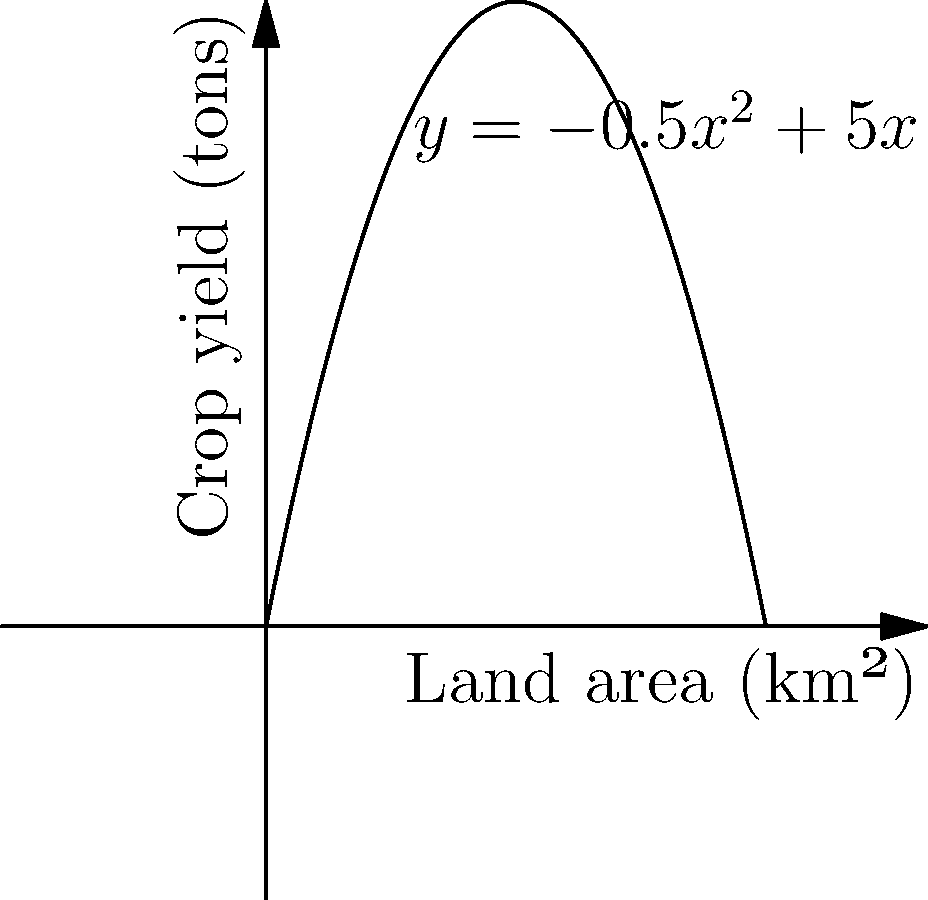In ancient Mesopotamia, agricultural output was crucial for sustaining the civilization. Archaeologists have modeled the relationship between land area cultivated and crop yield using the function $y = -0.5x^2 + 5x$, where $x$ represents the land area in square kilometers and $y$ represents the crop yield in tons. What is the optimal amount of land to cultivate to maximize crop yield, and what is the maximum yield? To find the optimal land area and maximum yield, we need to follow these steps:

1) The function $y = -0.5x^2 + 5x$ is a parabola that opens downward due to the negative coefficient of $x^2$.

2) The maximum point of a parabola occurs at its vertex. To find the vertex, we can use the formula $x = -\frac{b}{2a}$ where $a$ and $b$ are the coefficients of $x^2$ and $x$ respectively in the quadratic function $ax^2 + bx + c$.

3) In this case, $a = -0.5$ and $b = 5$. So:

   $x = -\frac{5}{2(-0.5)} = -\frac{5}{-1} = 5$

4) This means the optimal land area to cultivate is 5 square kilometers.

5) To find the maximum yield, we substitute $x = 5$ into the original function:

   $y = -0.5(5)^2 + 5(5) = -0.5(25) + 25 = -12.5 + 25 = 12.5$

6) Therefore, the maximum crop yield is 12.5 tons.
Answer: Optimal land area: 5 km²; Maximum yield: 12.5 tons 